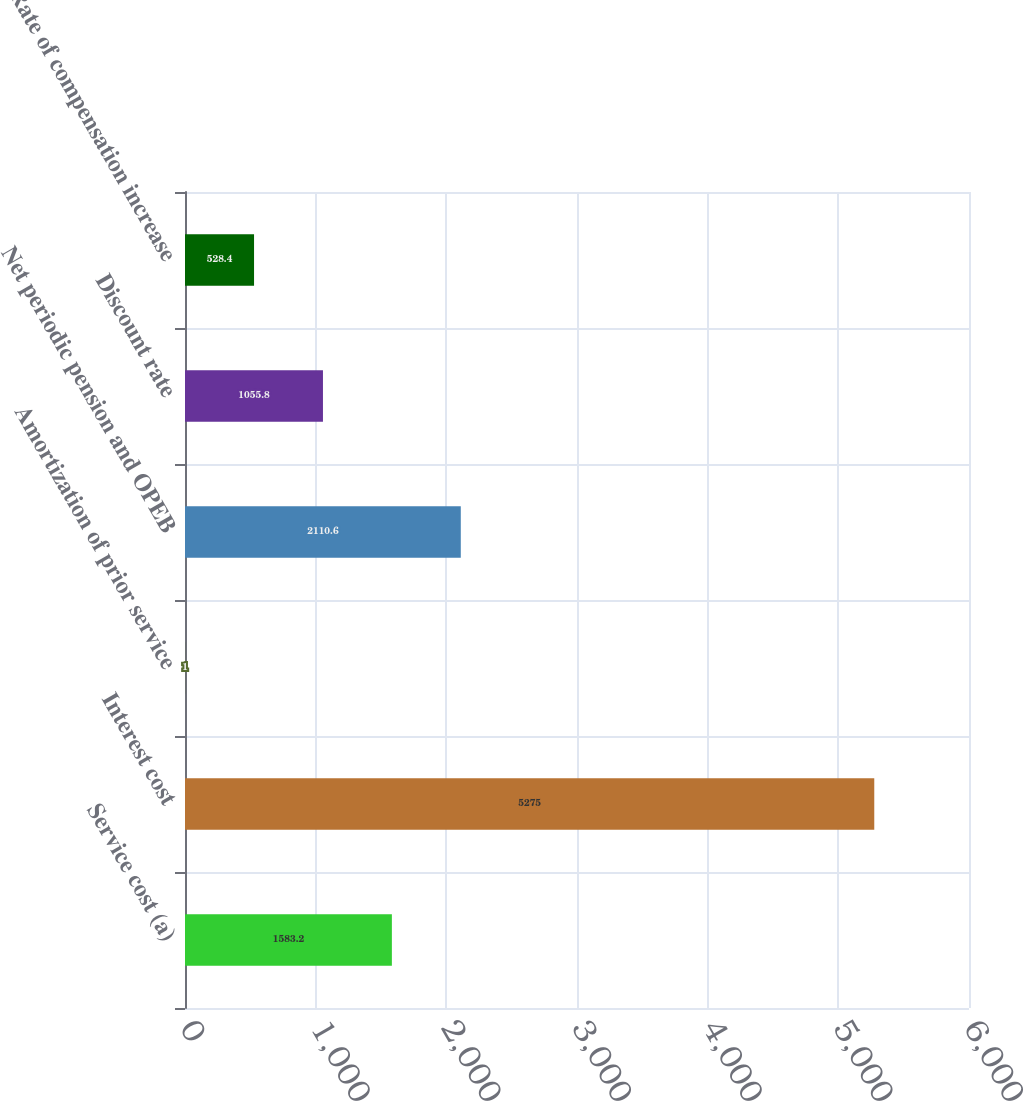Convert chart. <chart><loc_0><loc_0><loc_500><loc_500><bar_chart><fcel>Service cost (a)<fcel>Interest cost<fcel>Amortization of prior service<fcel>Net periodic pension and OPEB<fcel>Discount rate<fcel>Rate of compensation increase<nl><fcel>1583.2<fcel>5275<fcel>1<fcel>2110.6<fcel>1055.8<fcel>528.4<nl></chart> 